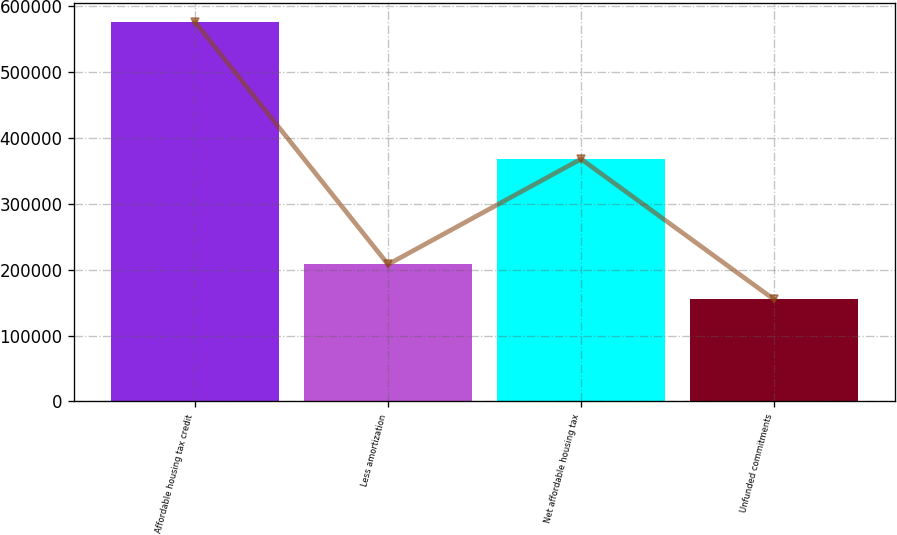<chart> <loc_0><loc_0><loc_500><loc_500><bar_chart><fcel>Affordable housing tax credit<fcel>Less amortization<fcel>Net affordable housing tax<fcel>Unfunded commitments<nl><fcel>576381<fcel>208098<fcel>368283<fcel>154861<nl></chart> 